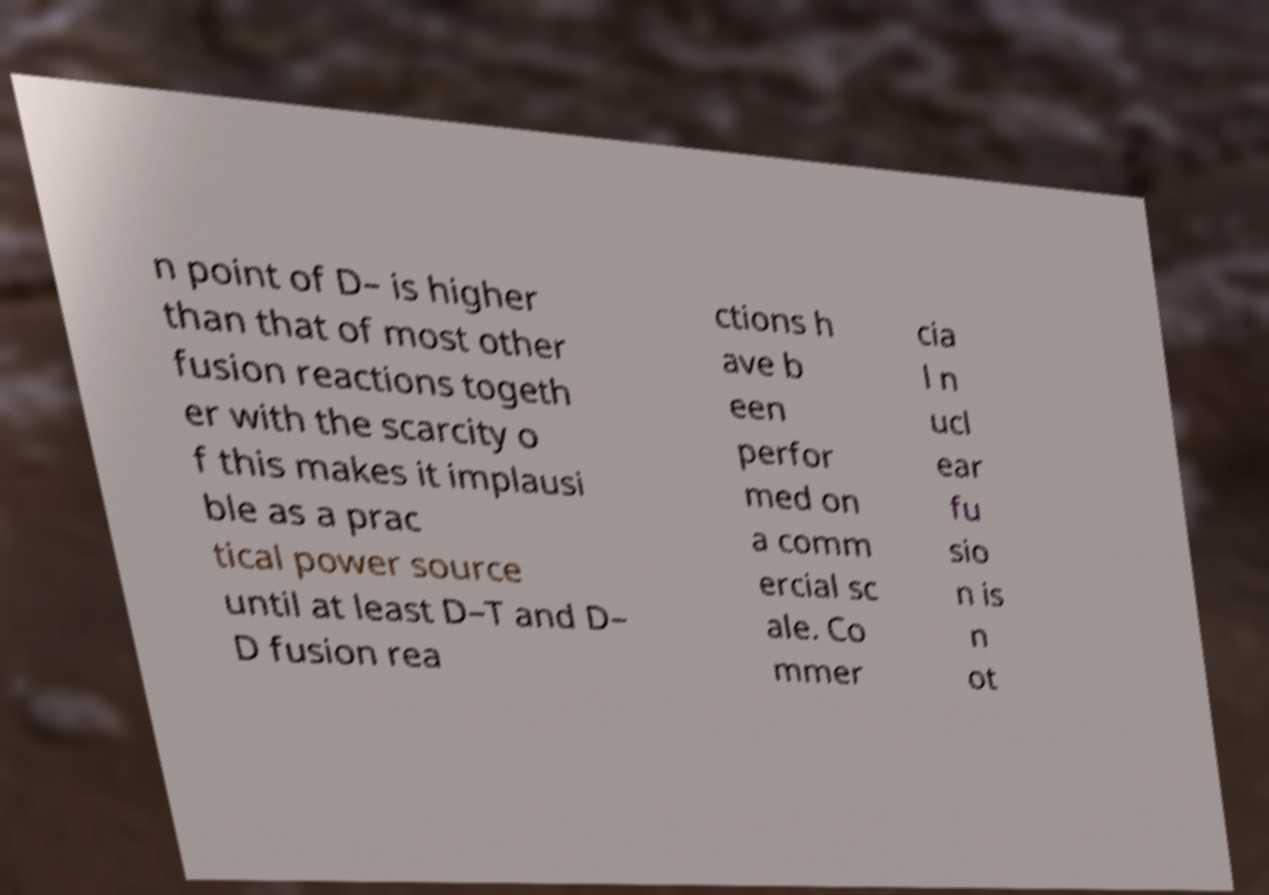Could you assist in decoding the text presented in this image and type it out clearly? n point of D– is higher than that of most other fusion reactions togeth er with the scarcity o f this makes it implausi ble as a prac tical power source until at least D–T and D– D fusion rea ctions h ave b een perfor med on a comm ercial sc ale. Co mmer cia l n ucl ear fu sio n is n ot 